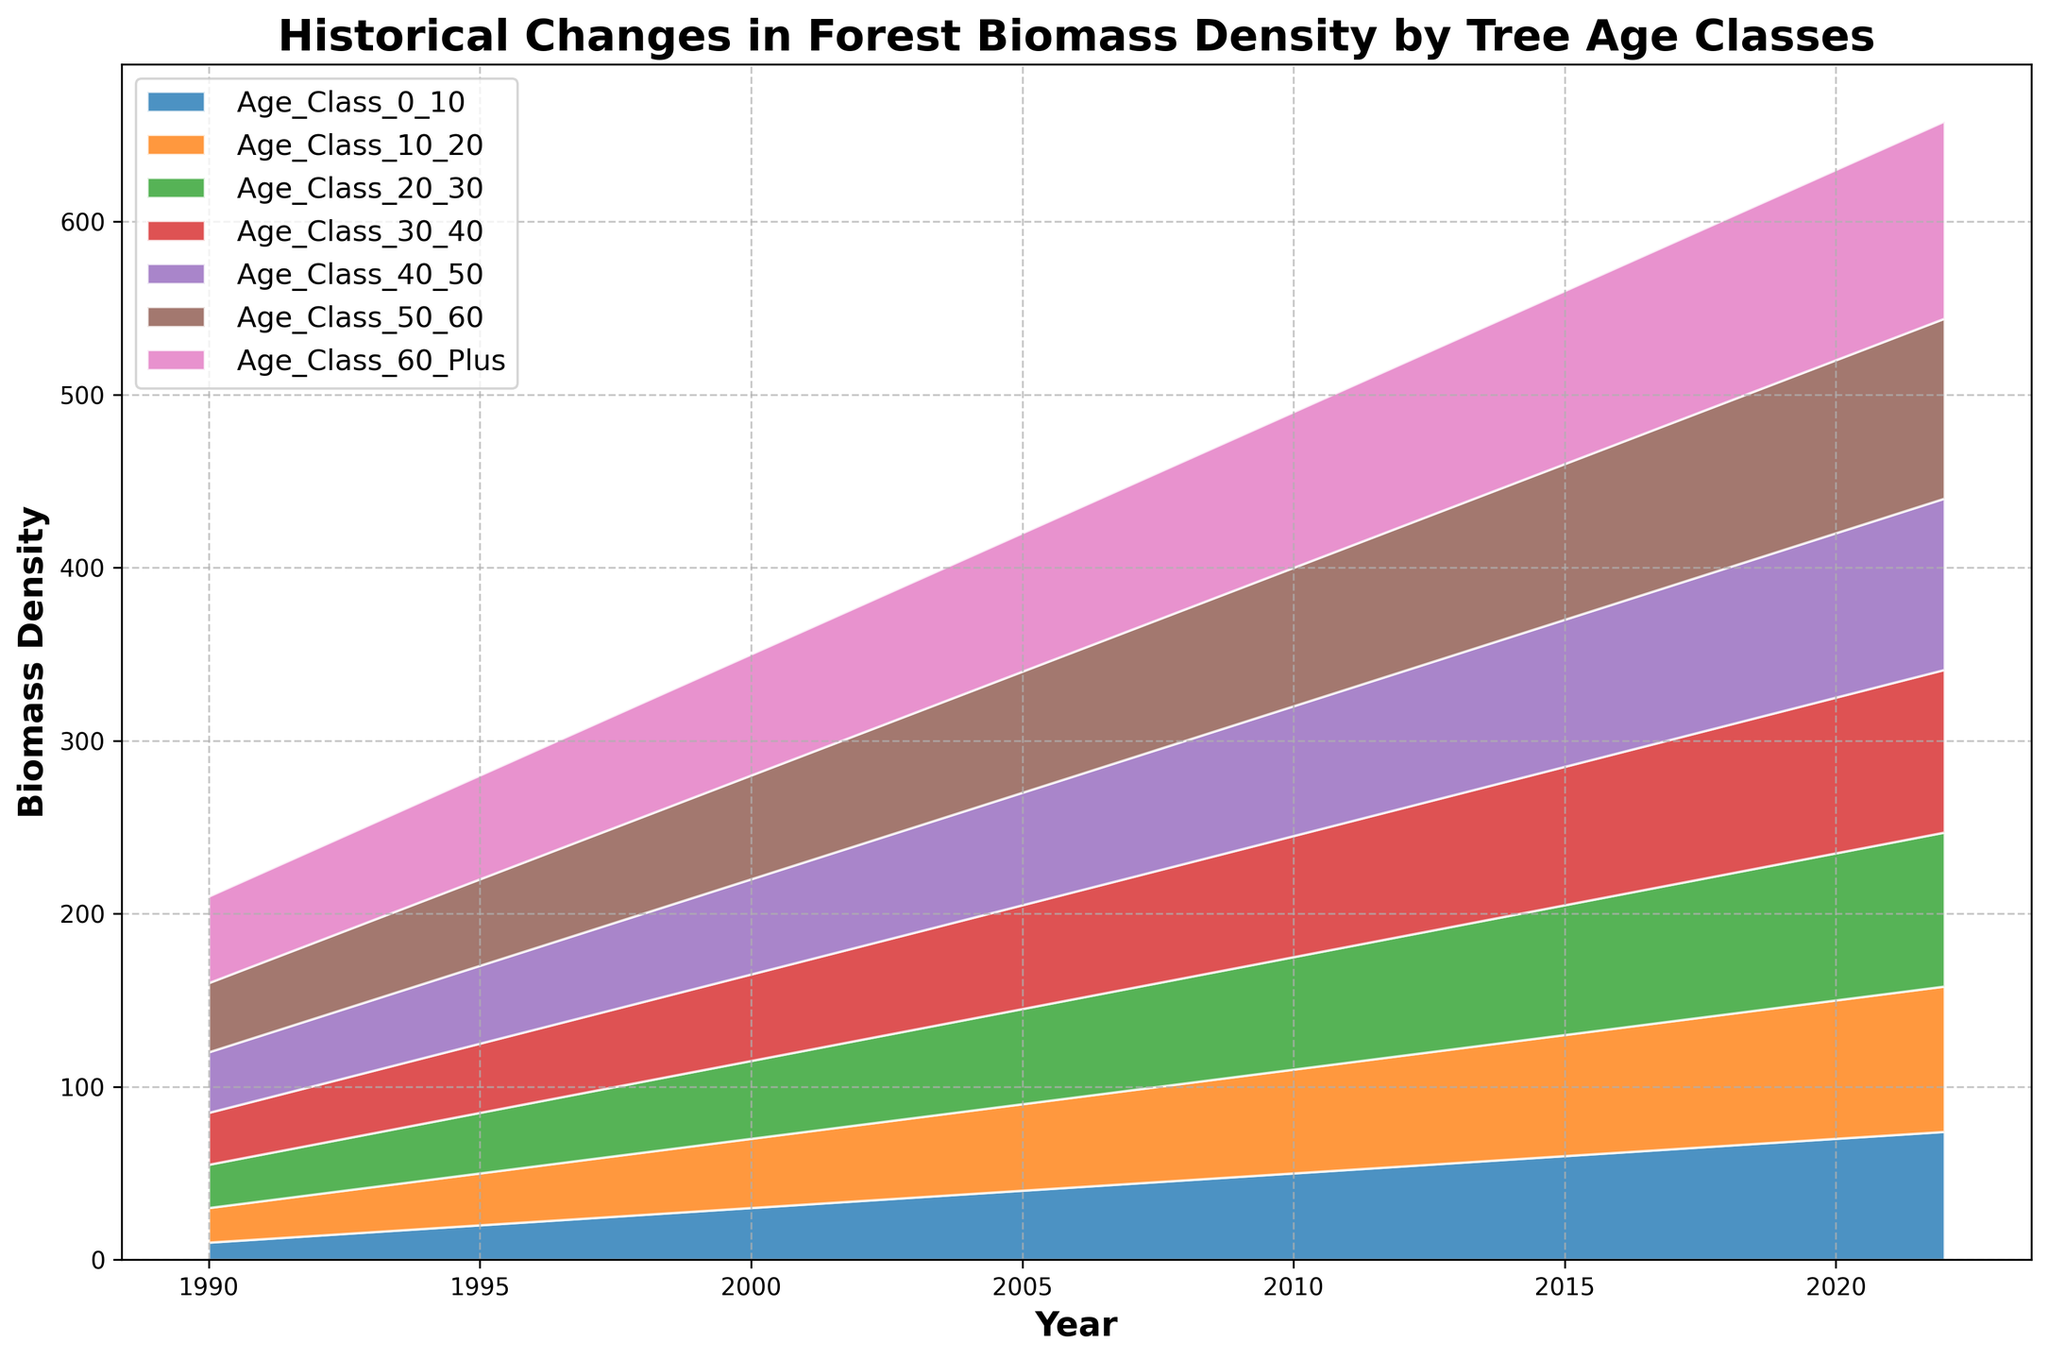What is the trend of biomass density in the Age Class 0-10 category over the years? The biomass density in the Age Class 0-10 category shows a consistent upward trend from 1990 to 2022. By visually examining the width of the color band representing this age class, we can see it increasing year after year.
Answer: Consistent upward trend Which age class had the highest biomass density in the year 2000? By looking at the height of the stacked area for each age class at the year 2000, we can see that the Age Class 60 Plus has the highest biomass density as it is the topmost segment in the plot.
Answer: Age Class 60 Plus What can you observe about the relative growth rates of Age Class 0-10 and Age Class 50-60 from 1990 to 2000? From 1990 to 2000, the slope for both age classes represents their growth rates. The Age Class 0-10 shows a steeper increase compared to Age Class 50-60, indicating a faster relative growth rate. This is observed by comparing the relative changes in the width of their segments.
Answer: Age Class 0-10 had a faster growth rate How much did the biomass density for Age Class 30-40 increase from 1990 to 2022? To find the increase, subtract the biomass density of Age Class 30-40 in 1990 (30) from that in 2022 (94). (94 - 30 = 64). Thus, the biomass density increased by 64 units.
Answer: 64 units Which age category experienced the least change in biomass density between 1990 and 2005? Examine each age class by comparing the segments at 1990 and 2005. The Age Class 50-60 increased from 40 to 70, totaling an increase of 30 units. This relatively small change indicates it experienced the least change.
Answer: Age Class 50-60 Is the rate of increase in biomass density uniform across all age classes? By analyzing the slopes of the lines representing the age classes over time, it's evident that not all age classes have the same rate of increase. For example, Age Class 0-10 has a steeper slope compared to Age Class 10-20, meaning the rate is not uniform.
Answer: No Which age class showed the most consistent growth trend from 1990 to 2022? Analyze the area for consistency by evaluating the smoothness of the slope for each segment. The Age Class 60 Plus exhibits a highly consistent growth trend as it steadily increases over time without any anomalies.
Answer: Age Class 60 Plus What was the approximate total biomass density for all age classes combined in 2010? Sum the values of biomass densities for all age classes in the year 2010 (50 + 60 + 65 + 70 + 75 + 80 + 90). The sum is 490 units.
Answer: 490 units In which period did the Age Class 20-30 show the highest acceleration in growth? By observing the slope changes for Age Class 20-30, its steepest increase occurs between 2010 and 2022 compared to earlier periods, indicating the highest acceleration in growth during this timeframe.
Answer: 2010-2022 How did the biomass density for Age Class 50-60 change from 2000 to 2020? The biomass density for Age Class 50-60 increased from 60 in 2000 to 100 in 2020. The change can be calculated as 100 - 60 = 40 units, representing an upward change of 40 units.
Answer: Increased by 40 units 